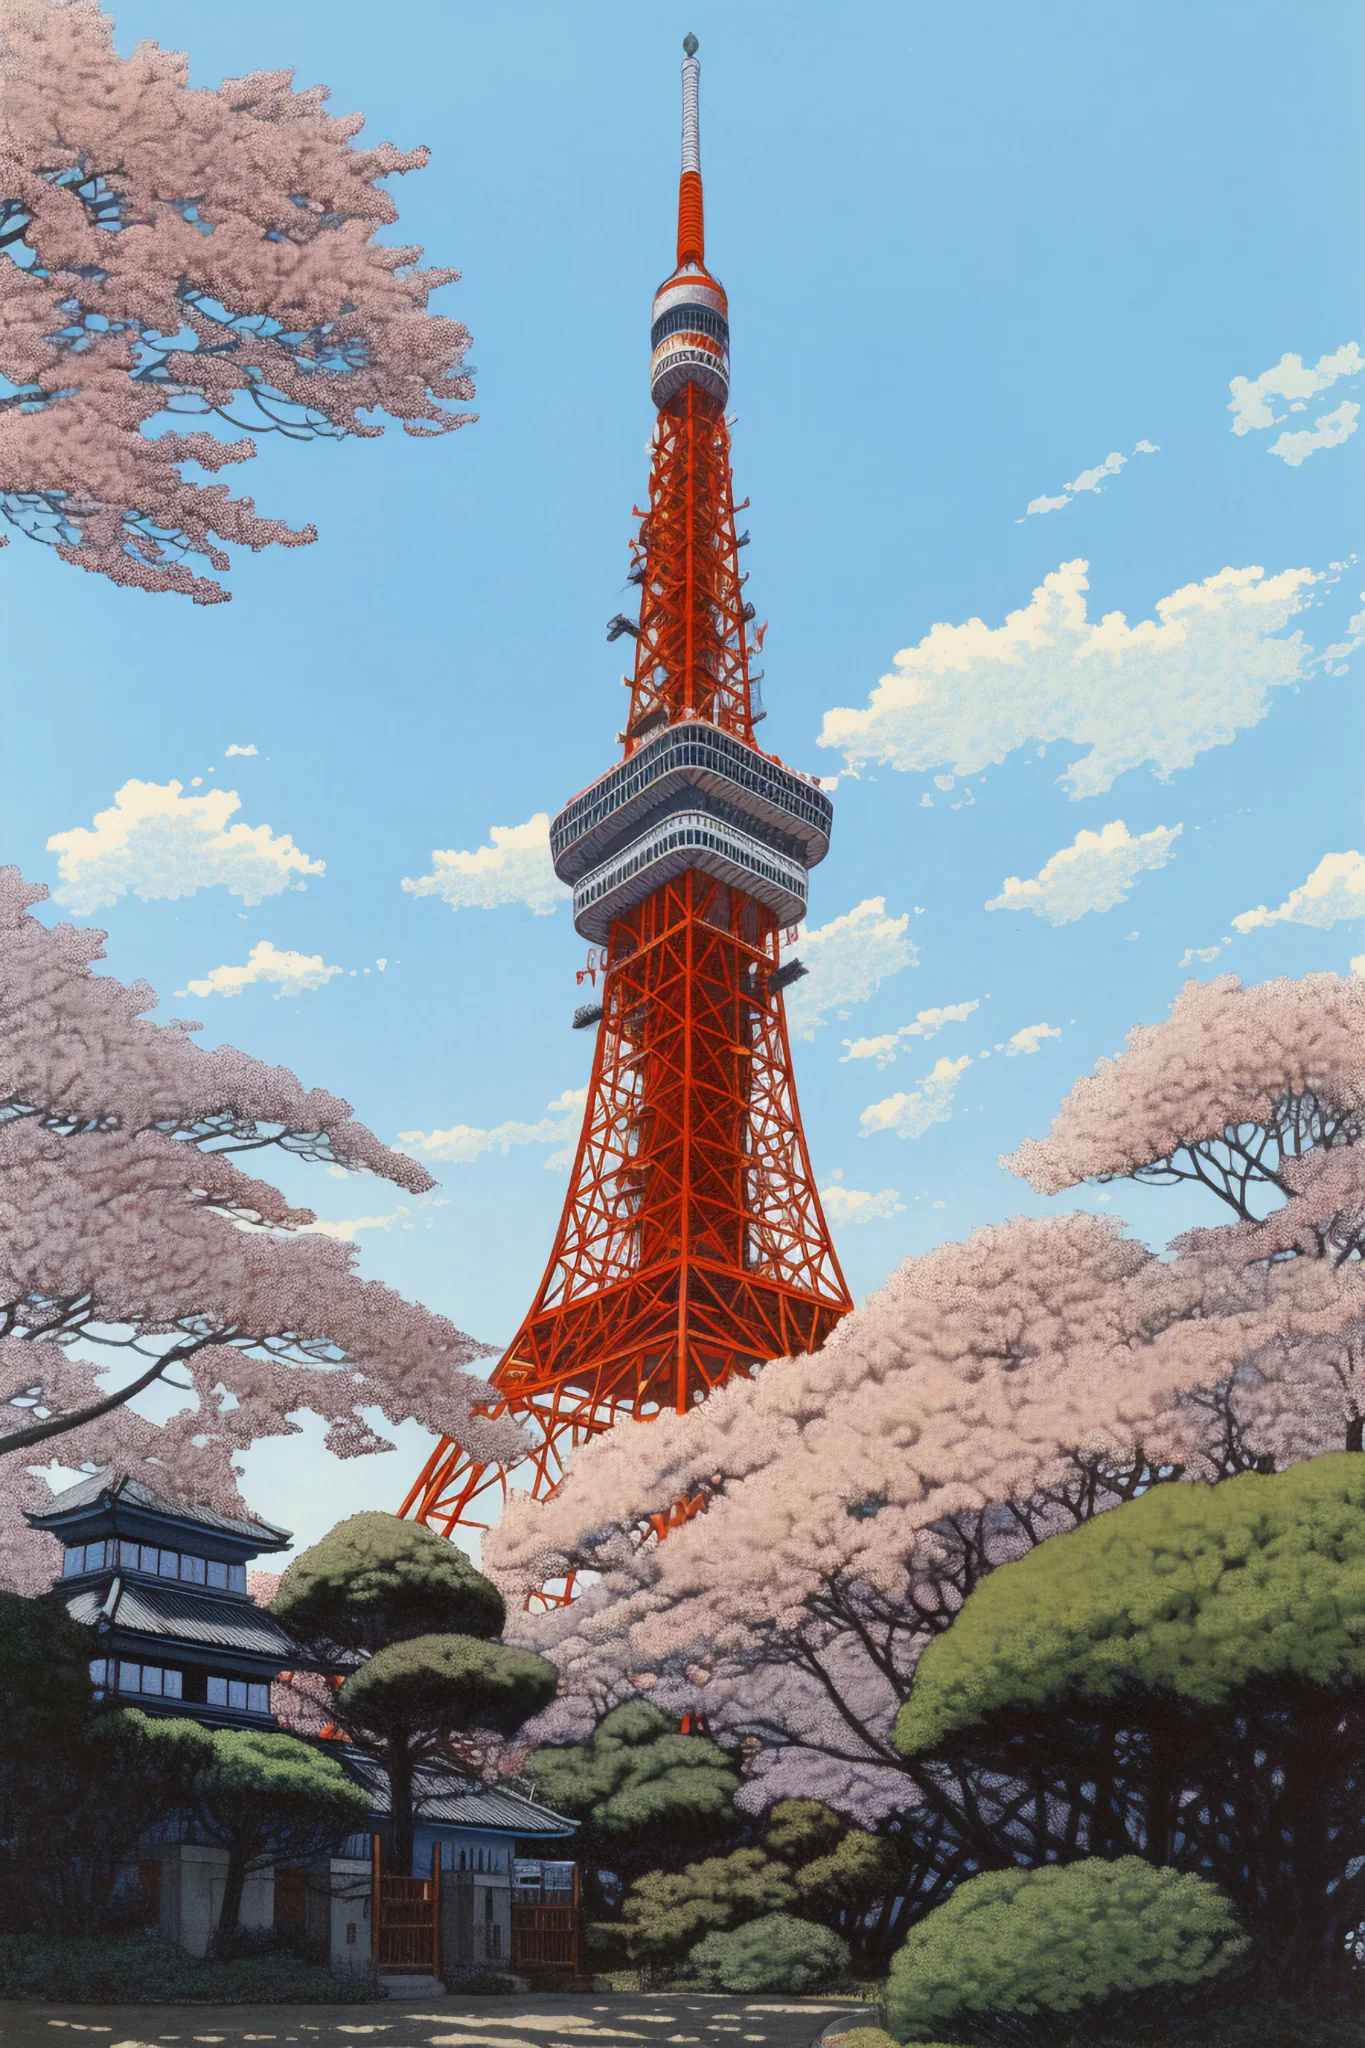Describe the atmosphere in the surrounding area during cherry blossom season. During cherry blossom season, the area around Tokyo Tower transforms into a breathtaking spectacle of pastel pinks and whites. The air is filled with a delightful fragrance from the sakura trees. Visitors and locals alike gather for 'hanami,' the traditional practice of admiring the transient beauty of cherry blossoms. The atmosphere is festive and serene at the sharegpt4v/same time, with people enjoying picnics under the blooming trees, taking countless photos, and leisurely strolling around the tower to soak in the vibrant yet peaceful ambiance. 